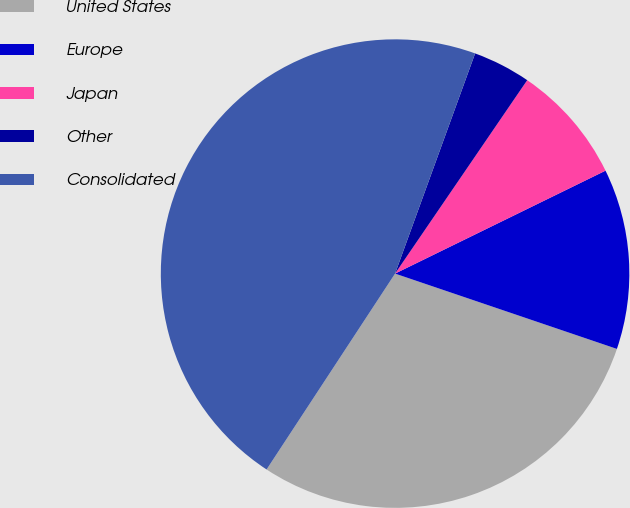Convert chart to OTSL. <chart><loc_0><loc_0><loc_500><loc_500><pie_chart><fcel>United States<fcel>Europe<fcel>Japan<fcel>Other<fcel>Consolidated<nl><fcel>29.03%<fcel>12.45%<fcel>8.22%<fcel>3.99%<fcel>46.31%<nl></chart> 